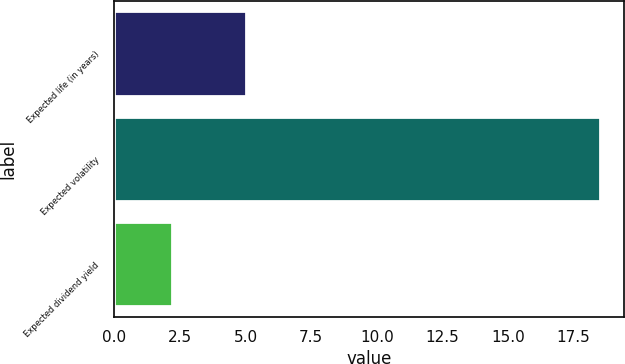<chart> <loc_0><loc_0><loc_500><loc_500><bar_chart><fcel>Expected life (in years)<fcel>Expected volatility<fcel>Expected dividend yield<nl><fcel>5<fcel>18.5<fcel>2.2<nl></chart> 